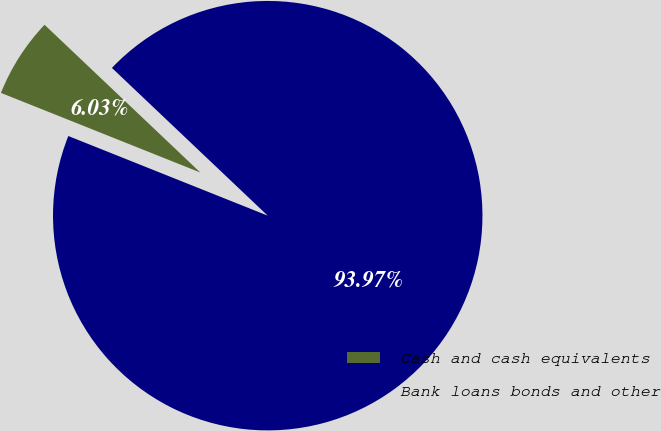Convert chart to OTSL. <chart><loc_0><loc_0><loc_500><loc_500><pie_chart><fcel>Cash and cash equivalents<fcel>Bank loans bonds and other<nl><fcel>6.03%<fcel>93.97%<nl></chart> 